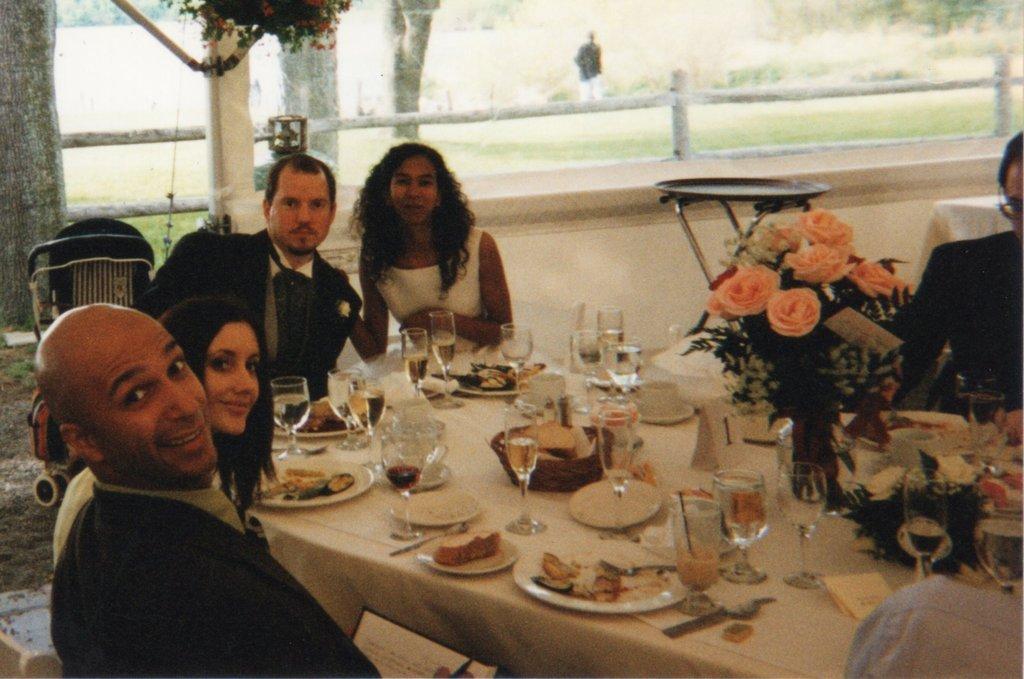Could you give a brief overview of what you see in this image? In this image can see the people sitting on the chairs in front of the dining table which is covered with the white cloth and on the table we can see the plates of food, glasses, flower vase, spoons, tissues and also the bowl of food items. In the background, we can see the chairs, trees, grass and also the wooden fence. We can also see a person. 